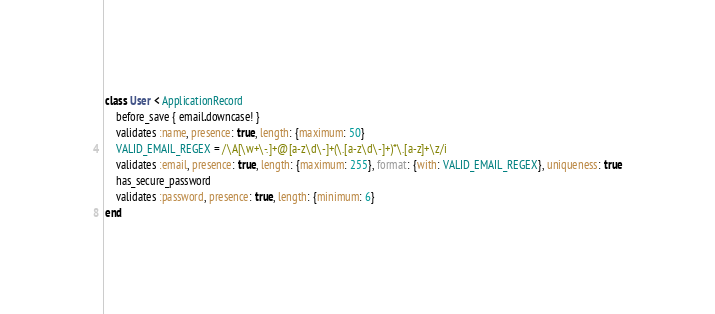<code> <loc_0><loc_0><loc_500><loc_500><_Ruby_>class User < ApplicationRecord
    before_save { email.downcase! }
    validates :name, presence: true, length: {maximum: 50}
    VALID_EMAIL_REGEX = /\A[\w+\-.]+@[a-z\d\-]+(\.[a-z\d\-]+)*\.[a-z]+\z/i
    validates :email, presence: true, length: {maximum: 255}, format: {with: VALID_EMAIL_REGEX}, uniqueness: true
    has_secure_password
    validates :password, presence: true, length: {minimum: 6}
end
</code> 